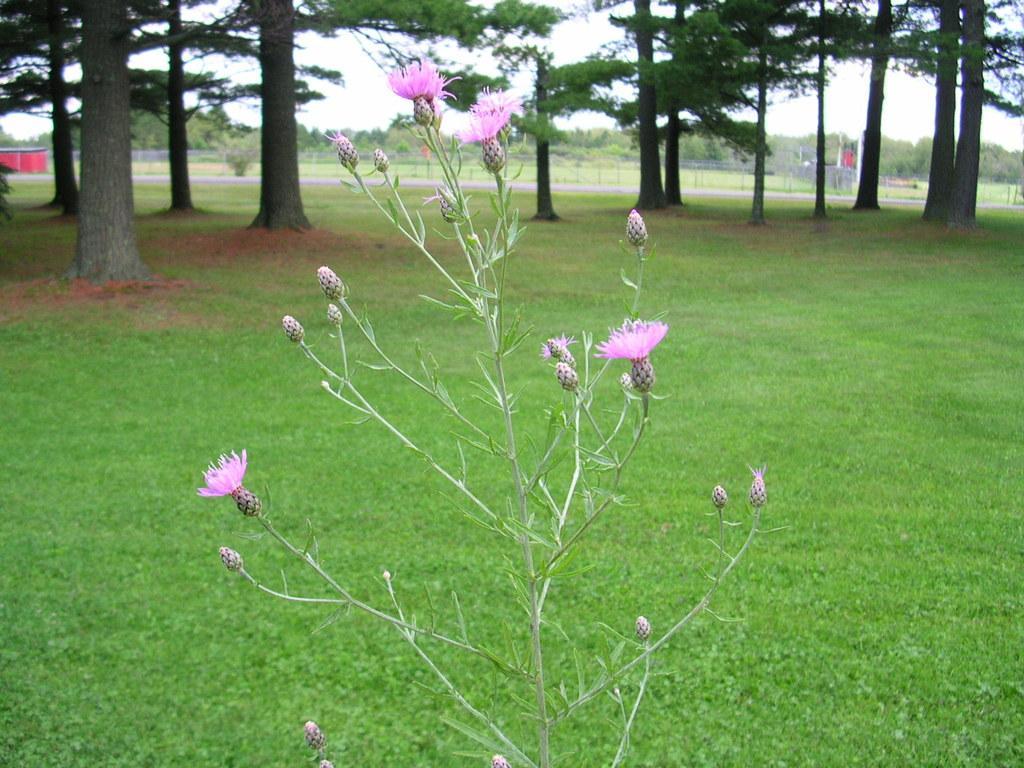In one or two sentences, can you explain what this image depicts? In the center of the image we can see a plant, flowers and buds. In the background of the image we can see the grass, trees, mesh, tent. In the middle of the image we can see the road. At the top of the image we can see the sky. 